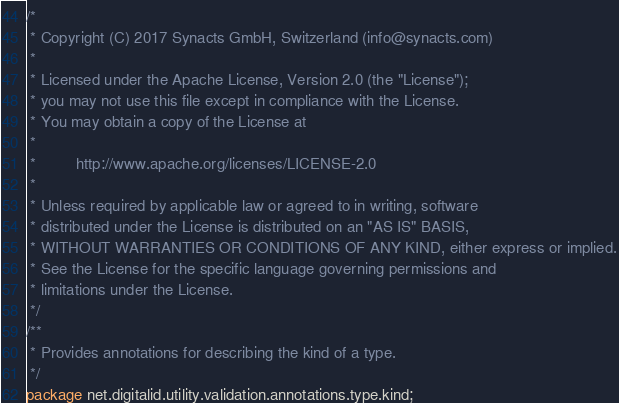<code> <loc_0><loc_0><loc_500><loc_500><_Java_>/*
 * Copyright (C) 2017 Synacts GmbH, Switzerland (info@synacts.com)
 *
 * Licensed under the Apache License, Version 2.0 (the "License");
 * you may not use this file except in compliance with the License.
 * You may obtain a copy of the License at
 *
 *         http://www.apache.org/licenses/LICENSE-2.0
 *
 * Unless required by applicable law or agreed to in writing, software
 * distributed under the License is distributed on an "AS IS" BASIS,
 * WITHOUT WARRANTIES OR CONDITIONS OF ANY KIND, either express or implied.
 * See the License for the specific language governing permissions and
 * limitations under the License.
 */
/**
 * Provides annotations for describing the kind of a type.
 */
package net.digitalid.utility.validation.annotations.type.kind;
</code> 